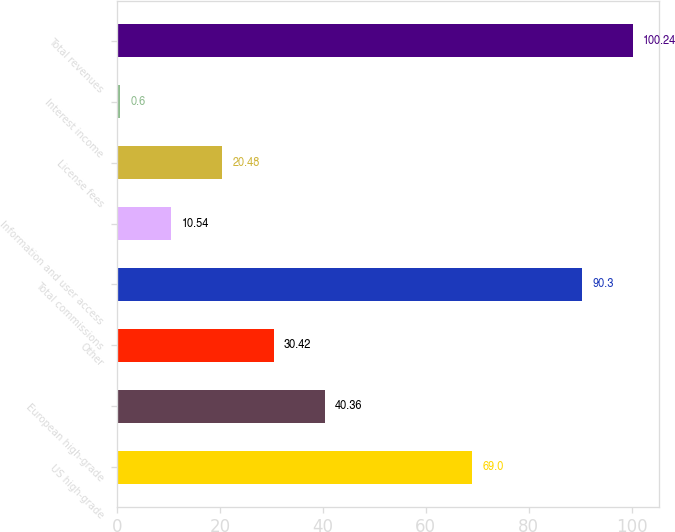<chart> <loc_0><loc_0><loc_500><loc_500><bar_chart><fcel>US high-grade<fcel>European high-grade<fcel>Other<fcel>Total commissions<fcel>Information and user access<fcel>License fees<fcel>Interest income<fcel>Total revenues<nl><fcel>69<fcel>40.36<fcel>30.42<fcel>90.3<fcel>10.54<fcel>20.48<fcel>0.6<fcel>100.24<nl></chart> 